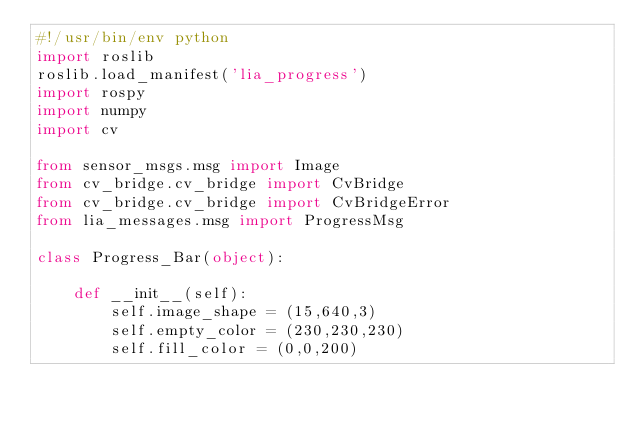Convert code to text. <code><loc_0><loc_0><loc_500><loc_500><_Python_>#!/usr/bin/env python
import roslib
roslib.load_manifest('lia_progress')
import rospy
import numpy
import cv

from sensor_msgs.msg import Image
from cv_bridge.cv_bridge import CvBridge 
from cv_bridge.cv_bridge import CvBridgeError
from lia_messages.msg import ProgressMsg

class Progress_Bar(object):

    def __init__(self):
        self.image_shape = (15,640,3)
        self.empty_color = (230,230,230)
        self.fill_color = (0,0,200)</code> 